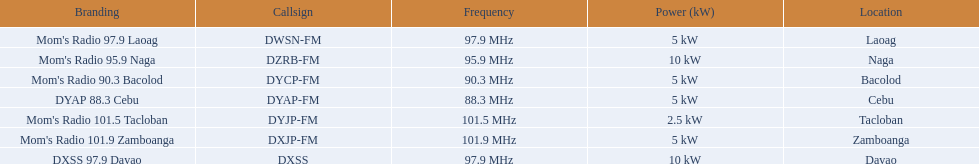Which stations transmit on dyap-fm? Mom's Radio 97.9 Laoag, Mom's Radio 95.9 Naga, Mom's Radio 90.3 Bacolod, DYAP 88.3 Cebu, Mom's Radio 101.5 Tacloban, Mom's Radio 101.9 Zamboanga, DXSS 97.9 Davao. Of those stations that transmit on dyap-fm, which ones operate with 5kw of power or less? Mom's Radio 97.9 Laoag, Mom's Radio 90.3 Bacolod, DYAP 88.3 Cebu, Mom's Radio 101.5 Tacloban, Mom's Radio 101.9 Zamboanga. Of those stations operating with 5kw of power or less, which one has the lowest power output? Mom's Radio 101.5 Tacloban. 